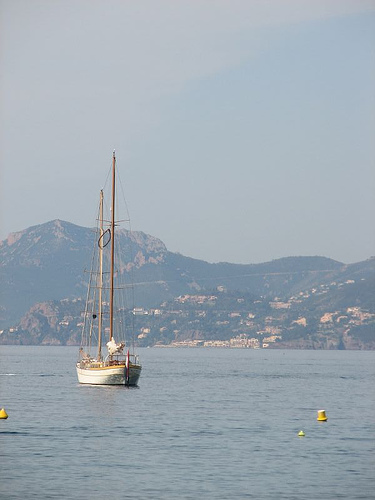<image>What animal is shown? There is no animal in the image. However, it can be seen as a bird or seal. What animal is shown? I don't know what animal is shown in the image. It is not clear from the given answers. 